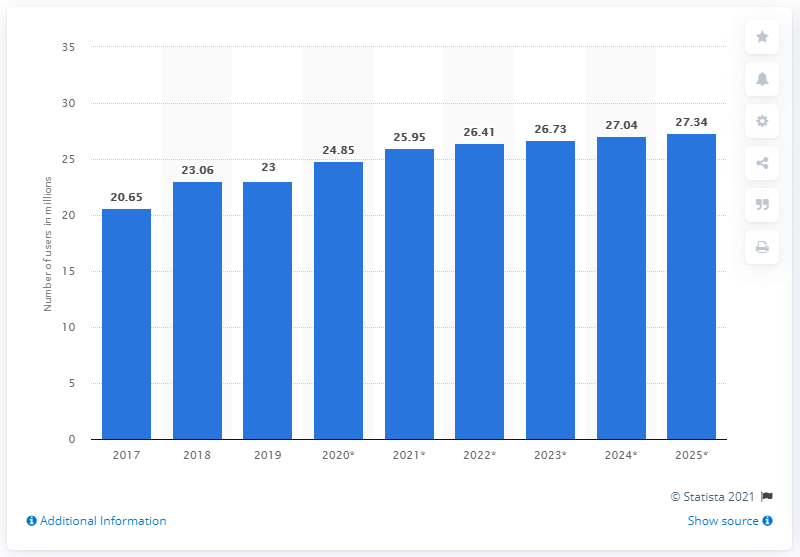Highlight a few significant elements in this photo. In 2019, there were approximately 23 million Facebook users in Malaysia. By 2025, it is expected that the number of Facebook users in Malaysia will reach 27.34 million. 